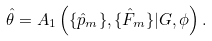Convert formula to latex. <formula><loc_0><loc_0><loc_500><loc_500>\hat { \theta } = A _ { 1 } \left ( \{ \hat { p } _ { m } \} , \{ \hat { F } _ { m } \} | G , \phi \right ) .</formula> 